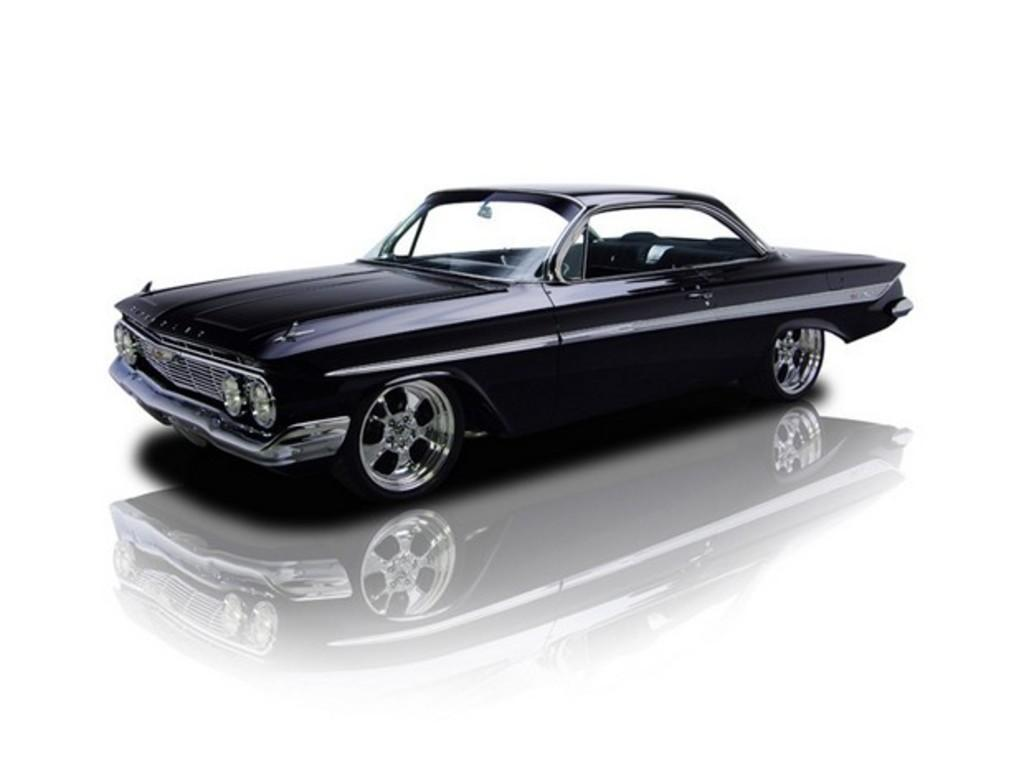What color is the vehicle in the image? The vehicle in the image is black. What color is the background of the image? The background of the image is white. Can you describe any additional features of the vehicle in the image? There is a reflection of the vehicle on the white surface. Are there any cobwebs visible in the image? There is no mention of cobwebs in the provided facts, so we cannot determine if any are present in the image. 